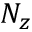<formula> <loc_0><loc_0><loc_500><loc_500>N _ { z }</formula> 